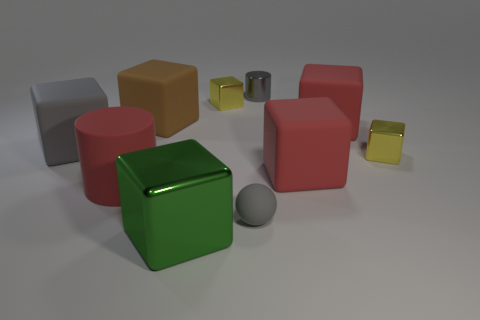Subtract all brown cubes. How many cubes are left? 6 Subtract all big shiny cubes. How many cubes are left? 6 Subtract all gray blocks. Subtract all red cylinders. How many blocks are left? 6 Subtract all cylinders. How many objects are left? 8 Add 6 gray objects. How many gray objects are left? 9 Add 4 tiny yellow things. How many tiny yellow things exist? 6 Subtract 0 brown cylinders. How many objects are left? 10 Subtract all gray shiny cylinders. Subtract all big red things. How many objects are left? 6 